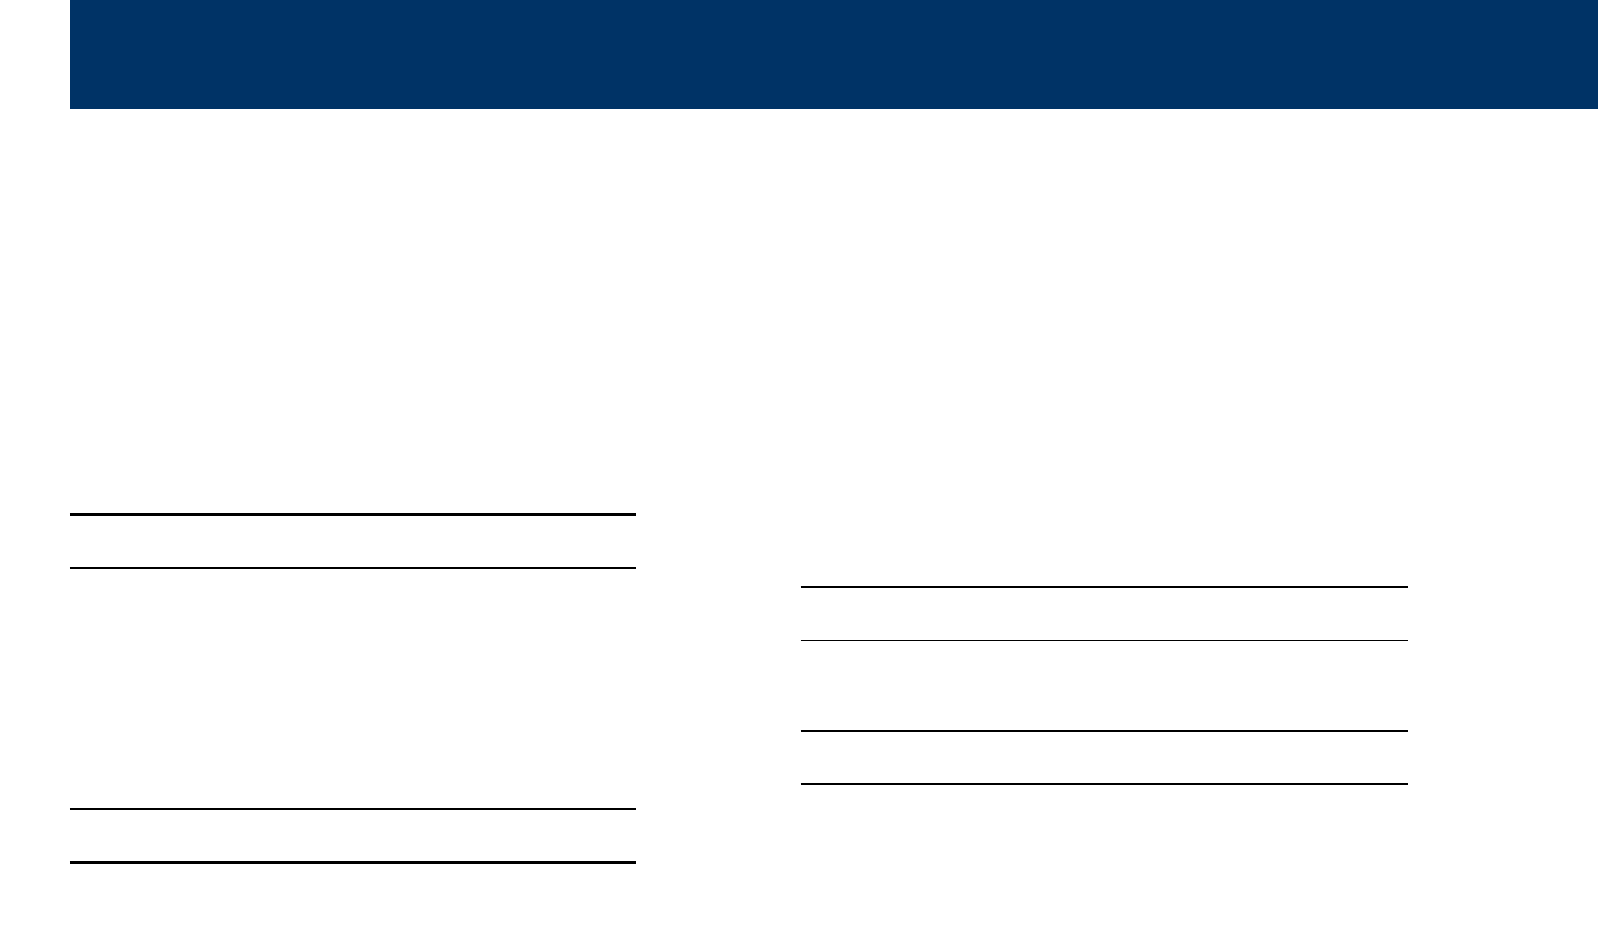What is the event title? The event title is listed at the beginning of the document, which is "Confidence Through Judo: Community Demonstration."
Answer: Confidence Through Judo: Community Demonstration What is the venue for the event? The venue is specified in the document under the relevant section, which is the "Riverside Community Center."
Answer: Riverside Community Center What is the date of the event? The date is indicated clearly in the document as "August 15, 2023."
Answer: August 15, 2023 What is the total amount of expenses? The total expenses are calculated by summing all itemized costs, which is $615.
Answer: 615 What is the total income expected from participant donations? The document specifies participant donations contributing a total income of $250.
Answer: 250 What is the net budget result? The net budget is derived from total expenses minus total income, which results in -$165.
Answer: -165 How many people are needed for the registration desk? The document states that 2 people are required for the registration desk.
Answer: 2 people At what time does clean-up begin? The document lists the time for clean-up as 4:30 PM.
Answer: 4:30 PM What is one of the roles of volunteers at the event? The document outlines various volunteer roles, with one being the refreshment station worker.
Answer: Refreshment station 